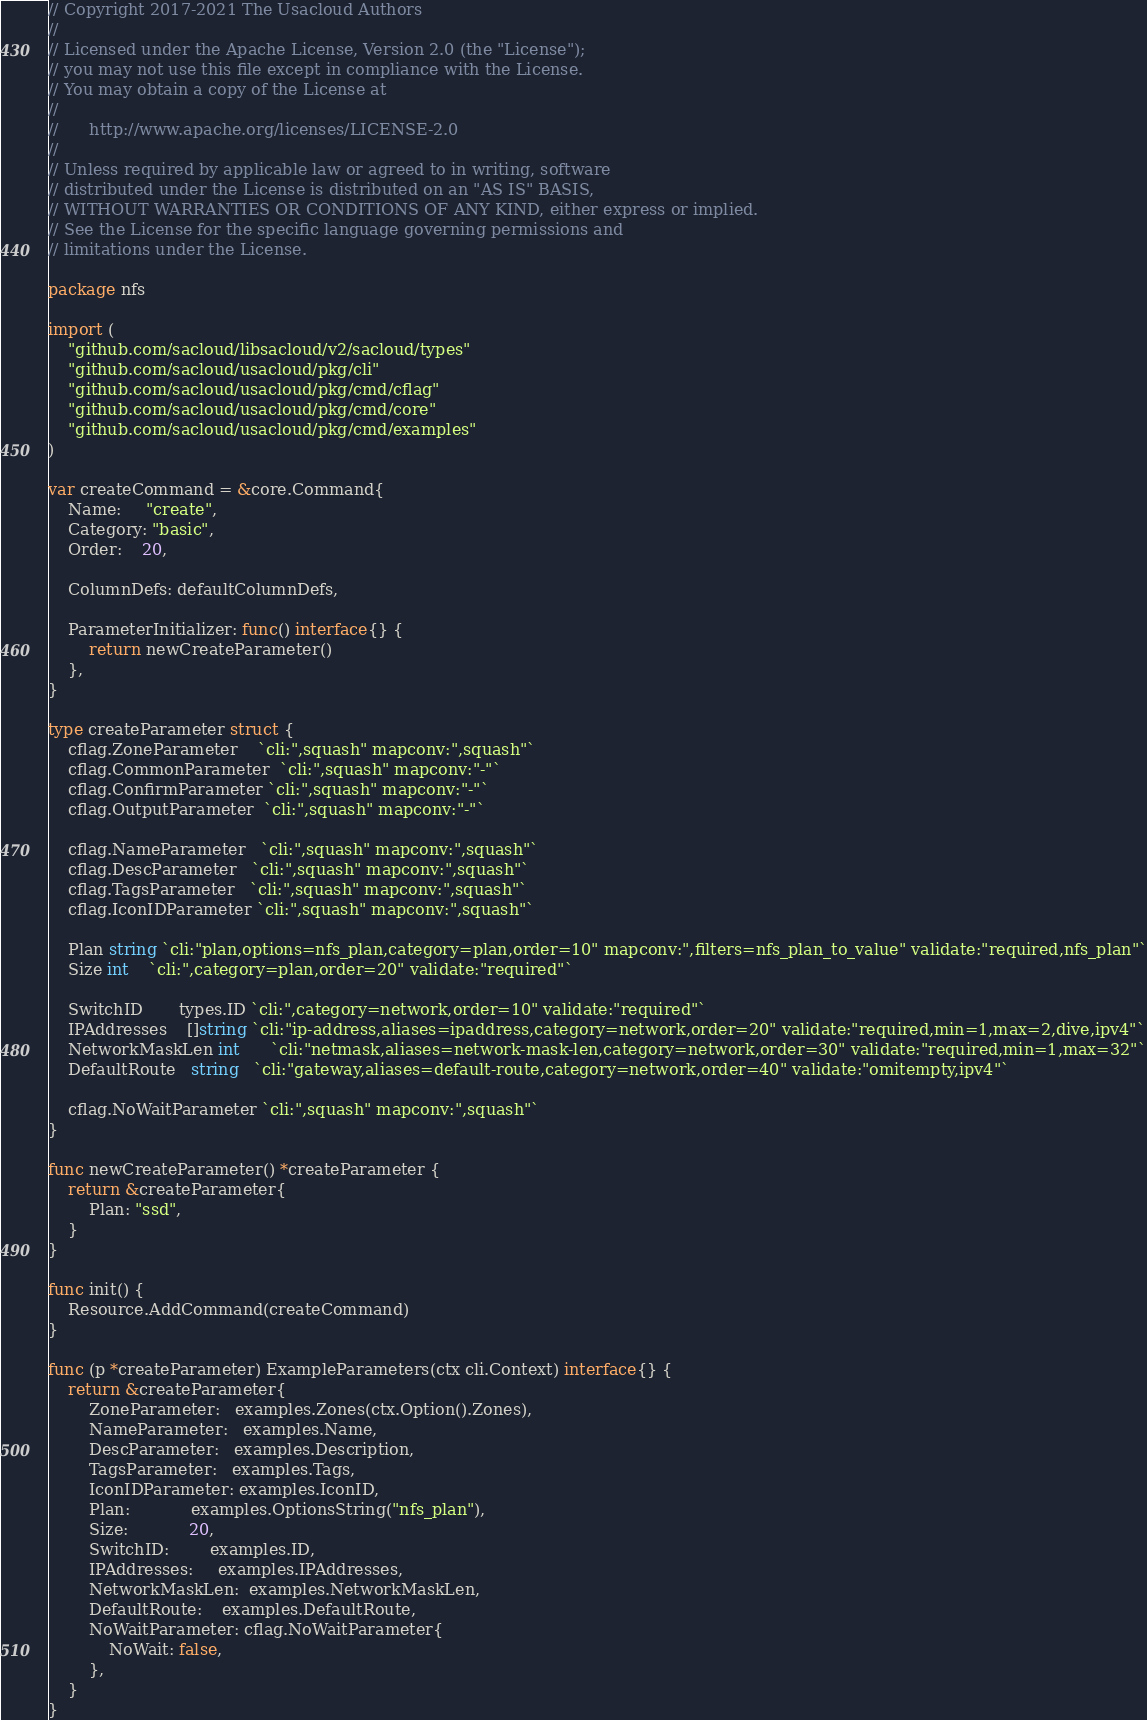Convert code to text. <code><loc_0><loc_0><loc_500><loc_500><_Go_>// Copyright 2017-2021 The Usacloud Authors
//
// Licensed under the Apache License, Version 2.0 (the "License");
// you may not use this file except in compliance with the License.
// You may obtain a copy of the License at
//
//      http://www.apache.org/licenses/LICENSE-2.0
//
// Unless required by applicable law or agreed to in writing, software
// distributed under the License is distributed on an "AS IS" BASIS,
// WITHOUT WARRANTIES OR CONDITIONS OF ANY KIND, either express or implied.
// See the License for the specific language governing permissions and
// limitations under the License.

package nfs

import (
	"github.com/sacloud/libsacloud/v2/sacloud/types"
	"github.com/sacloud/usacloud/pkg/cli"
	"github.com/sacloud/usacloud/pkg/cmd/cflag"
	"github.com/sacloud/usacloud/pkg/cmd/core"
	"github.com/sacloud/usacloud/pkg/cmd/examples"
)

var createCommand = &core.Command{
	Name:     "create",
	Category: "basic",
	Order:    20,

	ColumnDefs: defaultColumnDefs,

	ParameterInitializer: func() interface{} {
		return newCreateParameter()
	},
}

type createParameter struct {
	cflag.ZoneParameter    `cli:",squash" mapconv:",squash"`
	cflag.CommonParameter  `cli:",squash" mapconv:"-"`
	cflag.ConfirmParameter `cli:",squash" mapconv:"-"`
	cflag.OutputParameter  `cli:",squash" mapconv:"-"`

	cflag.NameParameter   `cli:",squash" mapconv:",squash"`
	cflag.DescParameter   `cli:",squash" mapconv:",squash"`
	cflag.TagsParameter   `cli:",squash" mapconv:",squash"`
	cflag.IconIDParameter `cli:",squash" mapconv:",squash"`

	Plan string `cli:"plan,options=nfs_plan,category=plan,order=10" mapconv:",filters=nfs_plan_to_value" validate:"required,nfs_plan"`
	Size int    `cli:",category=plan,order=20" validate:"required"`

	SwitchID       types.ID `cli:",category=network,order=10" validate:"required"`
	IPAddresses    []string `cli:"ip-address,aliases=ipaddress,category=network,order=20" validate:"required,min=1,max=2,dive,ipv4"`
	NetworkMaskLen int      `cli:"netmask,aliases=network-mask-len,category=network,order=30" validate:"required,min=1,max=32"`
	DefaultRoute   string   `cli:"gateway,aliases=default-route,category=network,order=40" validate:"omitempty,ipv4"`

	cflag.NoWaitParameter `cli:",squash" mapconv:",squash"`
}

func newCreateParameter() *createParameter {
	return &createParameter{
		Plan: "ssd",
	}
}

func init() {
	Resource.AddCommand(createCommand)
}

func (p *createParameter) ExampleParameters(ctx cli.Context) interface{} {
	return &createParameter{
		ZoneParameter:   examples.Zones(ctx.Option().Zones),
		NameParameter:   examples.Name,
		DescParameter:   examples.Description,
		TagsParameter:   examples.Tags,
		IconIDParameter: examples.IconID,
		Plan:            examples.OptionsString("nfs_plan"),
		Size:            20,
		SwitchID:        examples.ID,
		IPAddresses:     examples.IPAddresses,
		NetworkMaskLen:  examples.NetworkMaskLen,
		DefaultRoute:    examples.DefaultRoute,
		NoWaitParameter: cflag.NoWaitParameter{
			NoWait: false,
		},
	}
}
</code> 